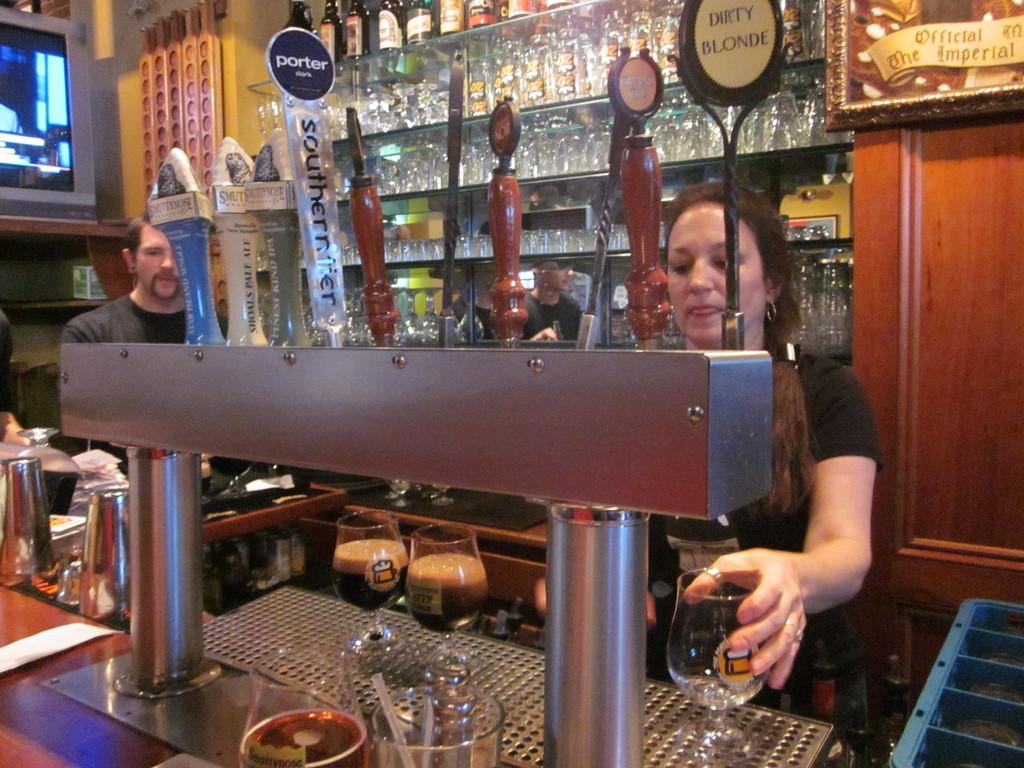<image>
Relay a brief, clear account of the picture shown. A woman stands behind a tab that has Dirty Blonde. 